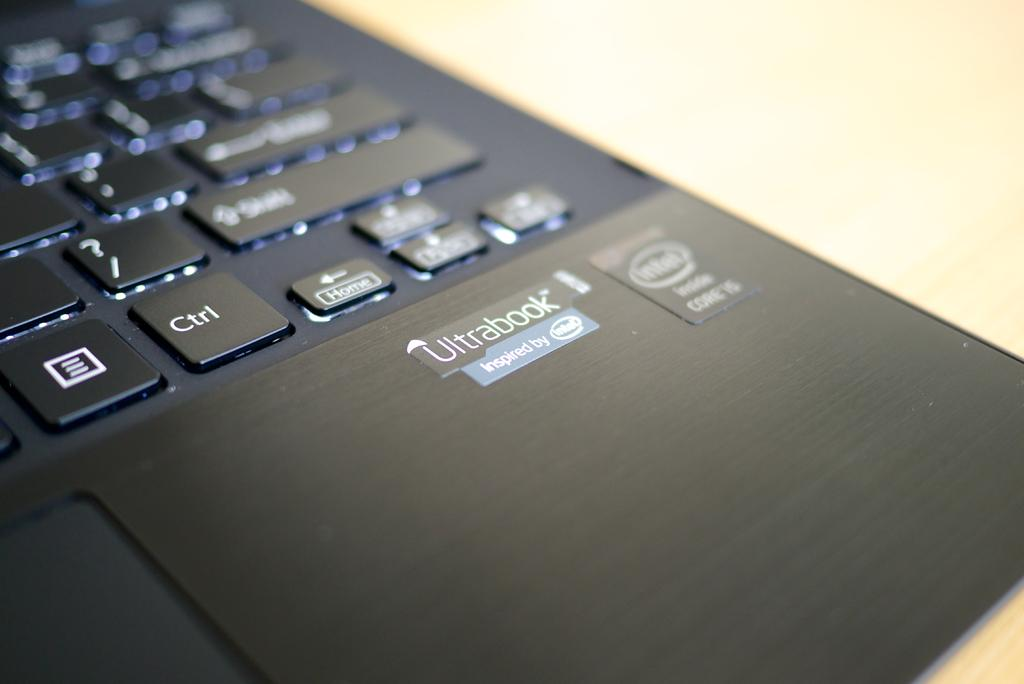<image>
Relay a brief, clear account of the picture shown. Bottom right corner of a black ultrabook is shown with its logo. 